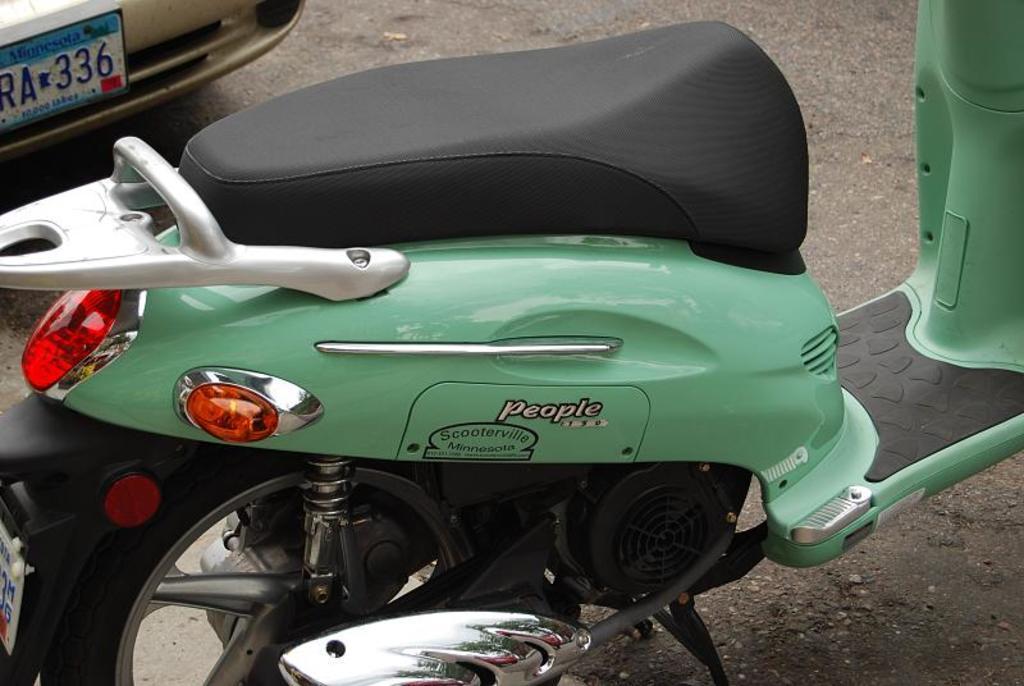How would you summarize this image in a sentence or two? This picture seems to be clicked outside. In the foreground we can see a scooter parked on the ground. In the background there is a vehicle and we can see the text and numbers on the number plate of the vehicle. 